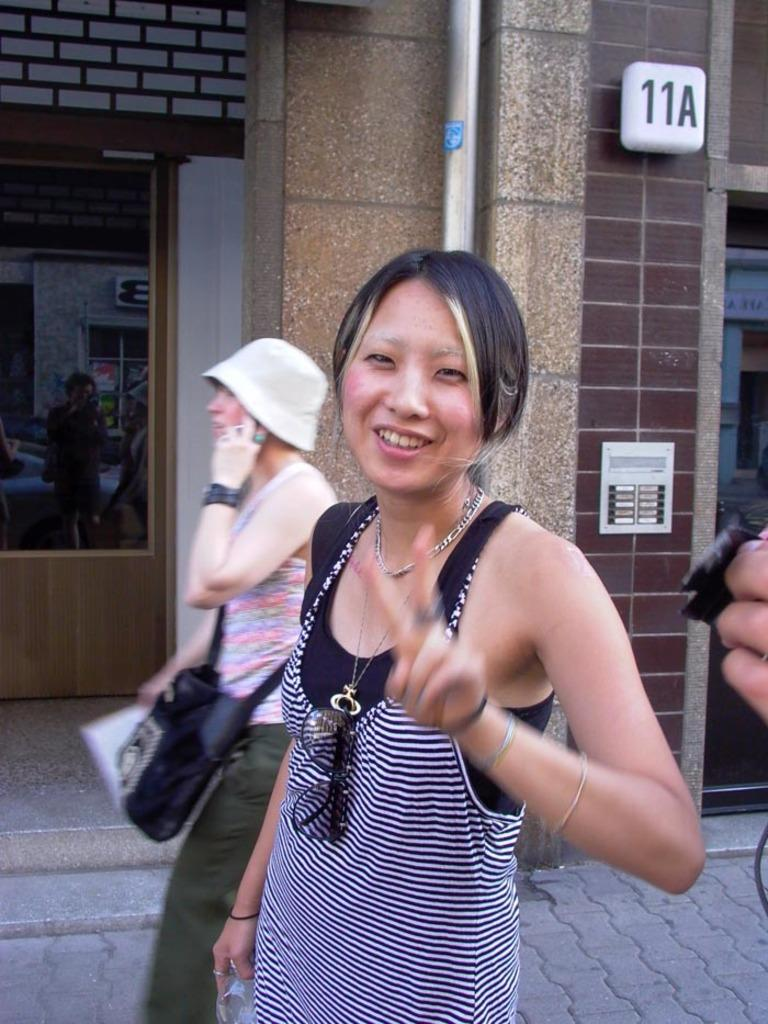What are the women in the image doing? The women are standing on the road in the image. What can be seen in the background of the image? There is a wall, a pipeline, and windows in the background of the image. What note is the woman holding in her elbow in the image? There is no woman holding a note in her elbow in the image. 